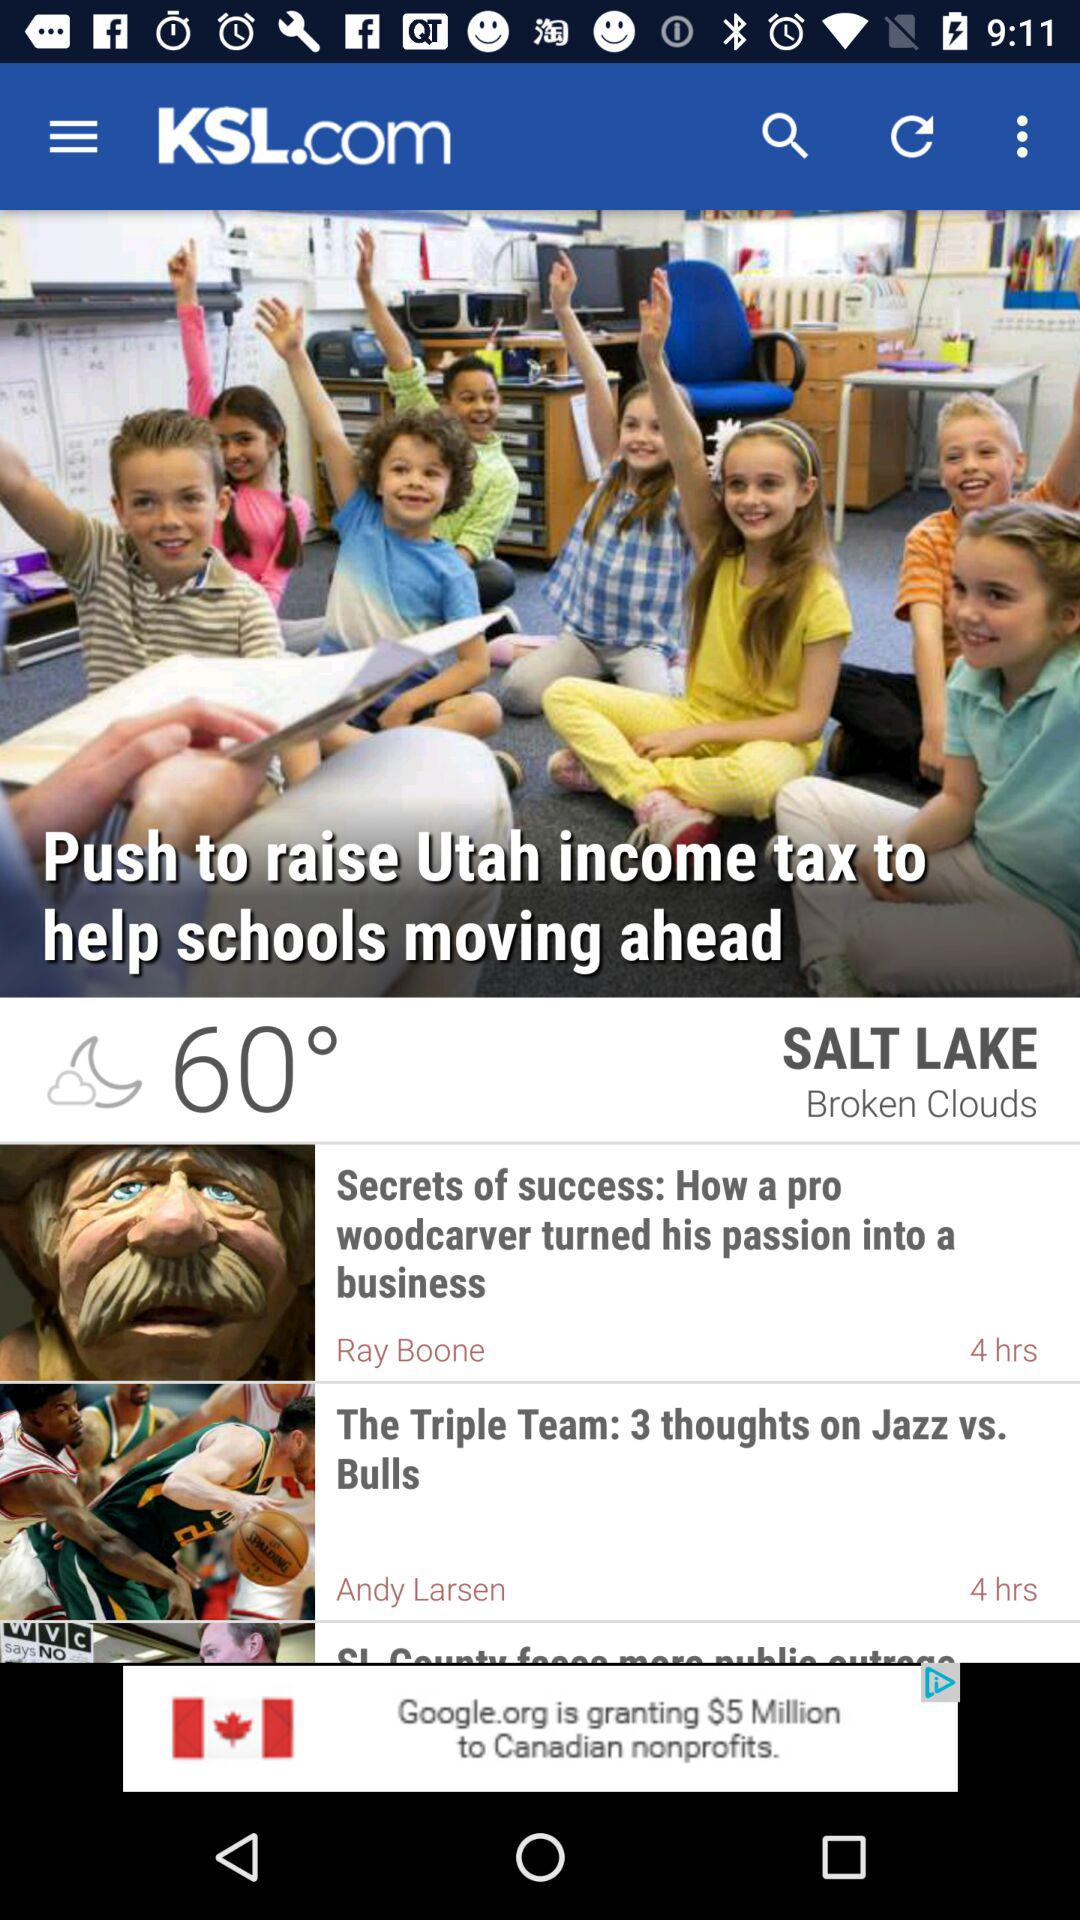What is the name of the application? The name of the application is "KSL.com". 